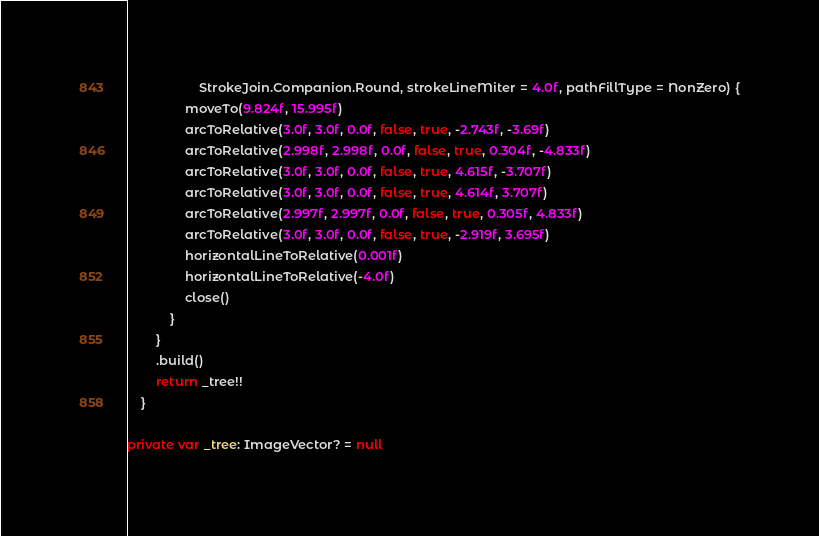Convert code to text. <code><loc_0><loc_0><loc_500><loc_500><_Kotlin_>                    StrokeJoin.Companion.Round, strokeLineMiter = 4.0f, pathFillType = NonZero) {
                moveTo(9.824f, 15.995f)
                arcToRelative(3.0f, 3.0f, 0.0f, false, true, -2.743f, -3.69f)
                arcToRelative(2.998f, 2.998f, 0.0f, false, true, 0.304f, -4.833f)
                arcToRelative(3.0f, 3.0f, 0.0f, false, true, 4.615f, -3.707f)
                arcToRelative(3.0f, 3.0f, 0.0f, false, true, 4.614f, 3.707f)
                arcToRelative(2.997f, 2.997f, 0.0f, false, true, 0.305f, 4.833f)
                arcToRelative(3.0f, 3.0f, 0.0f, false, true, -2.919f, 3.695f)
                horizontalLineToRelative(0.001f)
                horizontalLineToRelative(-4.0f)
                close()
            }
        }
        .build()
        return _tree!!
    }

private var _tree: ImageVector? = null
</code> 